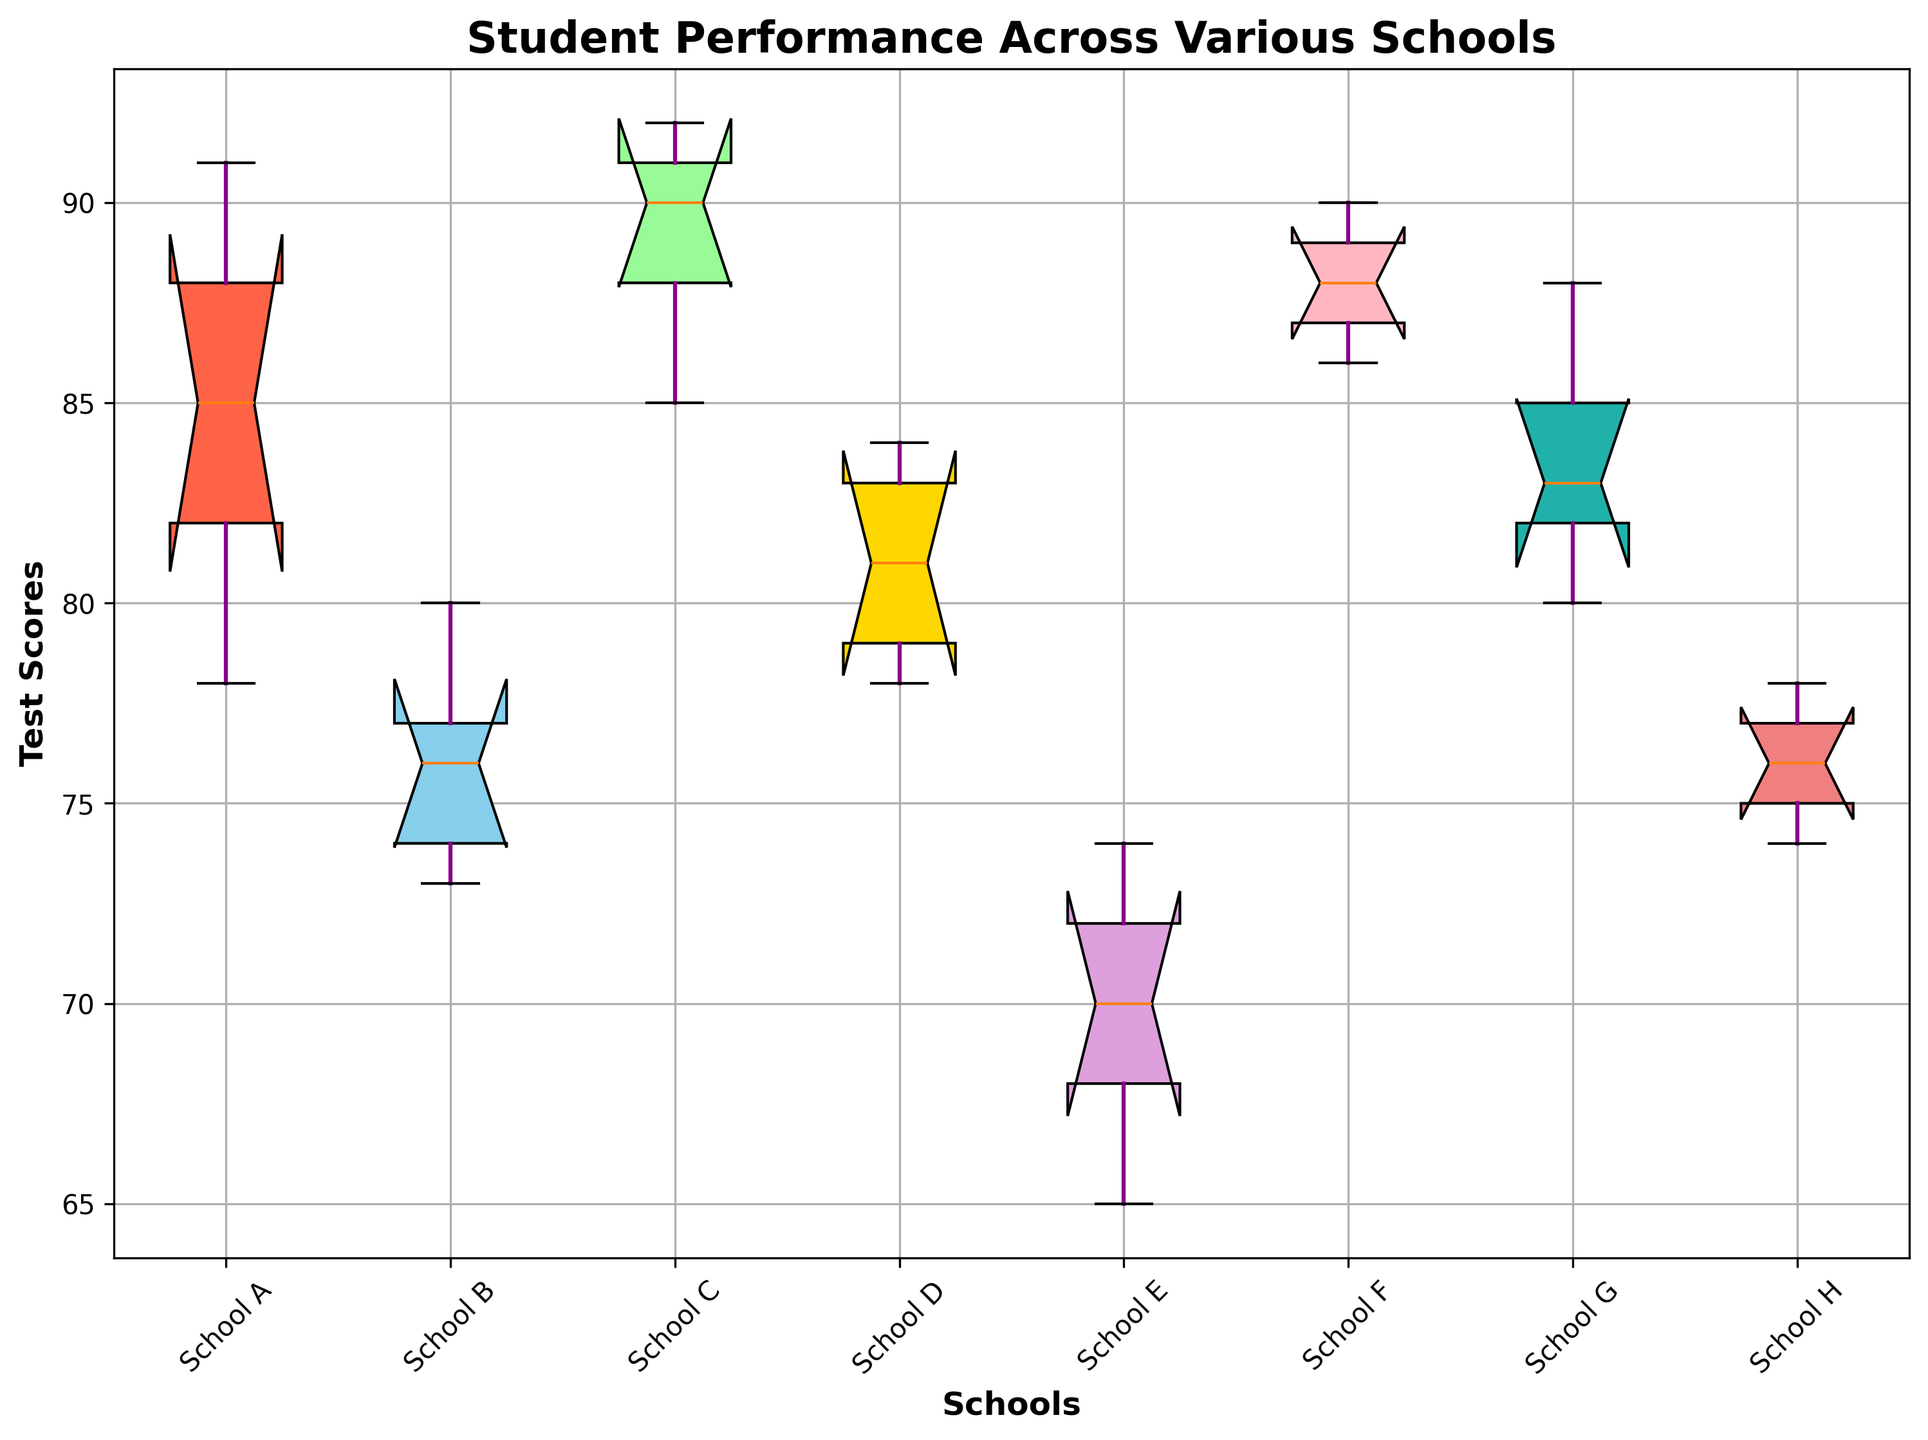Which school has the highest median test score? The box plot highlights the median value of each school with a horizontal line inside each box. The highest median value corresponds to School C.
Answer: School C Which schools have similar interquartile ranges (IQR) for their test scores? The IQR is represented by the height of the box in each school's plot. Schools B, D, and G have similarly sized IQRs, indicating a comparable middle 50% range of test scores.
Answer: Schools B, D, G Which district appears to have the most overall test score variability? The height of the whiskers and size of the boxes across all schools in each district collectively show variability. The East district, with schools E and F, shows a broad range and variability in test scores.
Answer: East district What is the difference between the upper quartile (Q3) and lower quartile (Q1) for School A? The upper quartile (Q3) and lower quartile (Q1) values are located at the top and bottom of the box. For School A, Q3 is around 88 and Q1 is around 82, so the difference is 88 - 82.
Answer: 6 How does the range of test scores in school E compare to that in School F? The range is represented by the distance between the minimum and maximum values in the whiskers. School E ranges from approximately 65 to 74, and School F ranges from approximately 86 to 90, showing School F has a narrower range.
Answer: School F has a narrower range Which school has the largest number of potential outliers in the test scores? Outliers in box plots are represented by individual points outside the whiskers. School E has several potential outliers, represented as individual points above the whiskers.
Answer: School E Which school shows the lowest minimum test score? The minimum test score is represented by the bottom whisker. School E shows the lowest minimum score, around the value of 65.
Answer: School E What is the median difference in test scores between Schools G and H? The median value can be found within each box (middle horizontal line). The median for School G is around 83, and for School H, it is around 76. The difference is 83 - 76.
Answer: 7 Are there any schools whose box plot is almost entirely above or below other schools? School F’s box plot is nearly entirely above Schools E and H, indicating School F’s lower quartile is above the upper quartile of these two schools.
Answer: School F above Schools E and H 